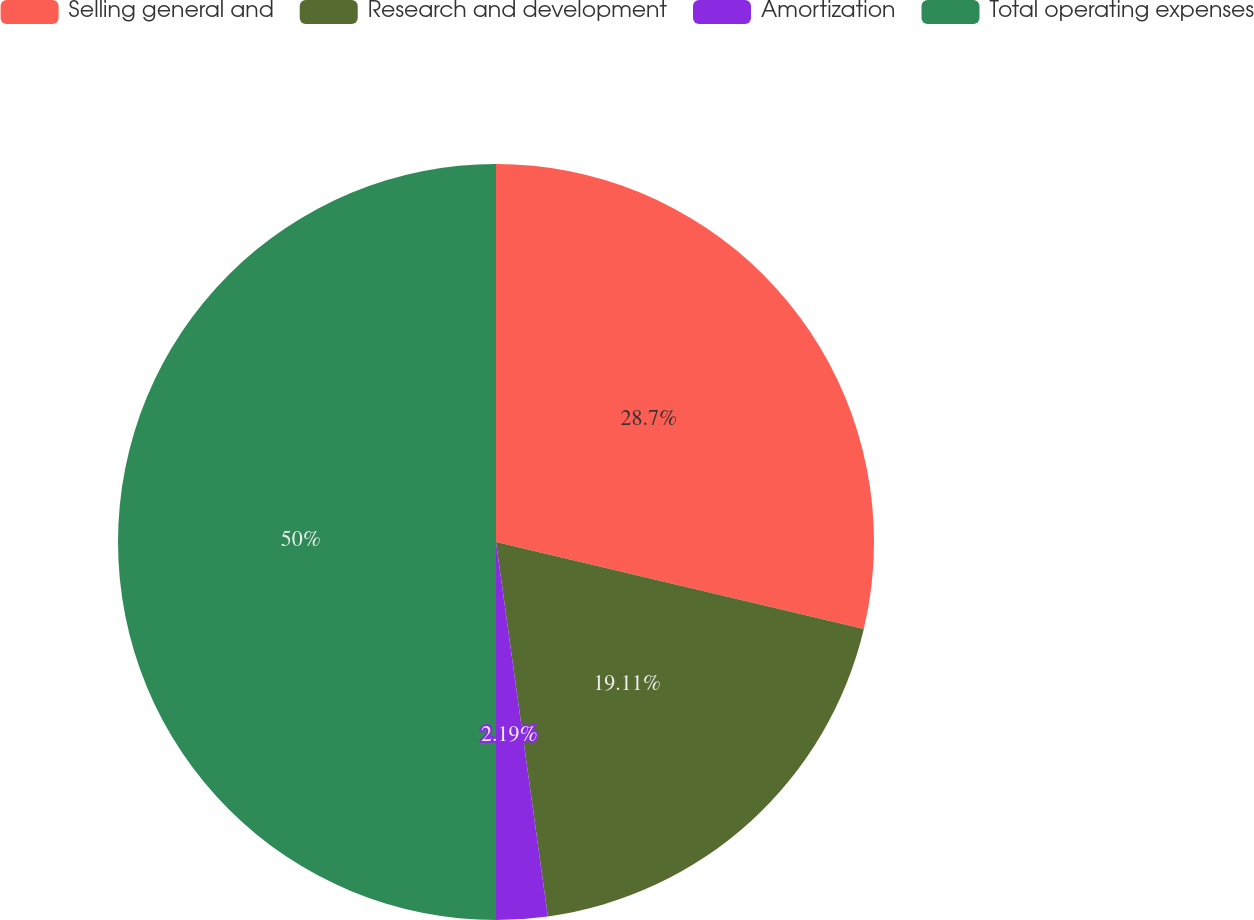Convert chart. <chart><loc_0><loc_0><loc_500><loc_500><pie_chart><fcel>Selling general and<fcel>Research and development<fcel>Amortization<fcel>Total operating expenses<nl><fcel>28.7%<fcel>19.11%<fcel>2.19%<fcel>50.0%<nl></chart> 